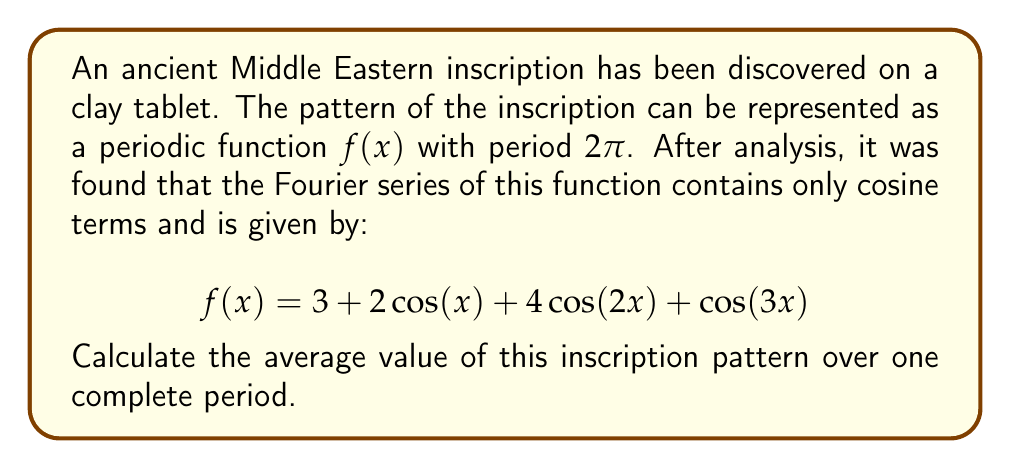What is the answer to this math problem? To find the average value of a periodic function over one complete period, we can use the concept of the constant term (a₀) in the Fourier series. The constant term represents the average value of the function over its period.

In a general Fourier series representation:

$$f(x) = \frac{a_0}{2} + \sum_{n=1}^{\infty} (a_n \cos(nx) + b_n \sin(nx))$$

The average value is given by $\frac{a_0}{2}$.

In our case, the Fourier series is already given in the form:

$$f(x) = 3 + 2\cos(x) + 4\cos(2x) + \cos(3x)$$

Comparing this with the general form, we can see that:

1) There are no sine terms (all $b_n = 0$)
2) The constant term is not divided by 2

Therefore, in this representation, the constant term (3) is already equal to $\frac{a_0}{2}$.

Thus, the average value of the function over one period is simply the constant term, which is 3.
Answer: 3 